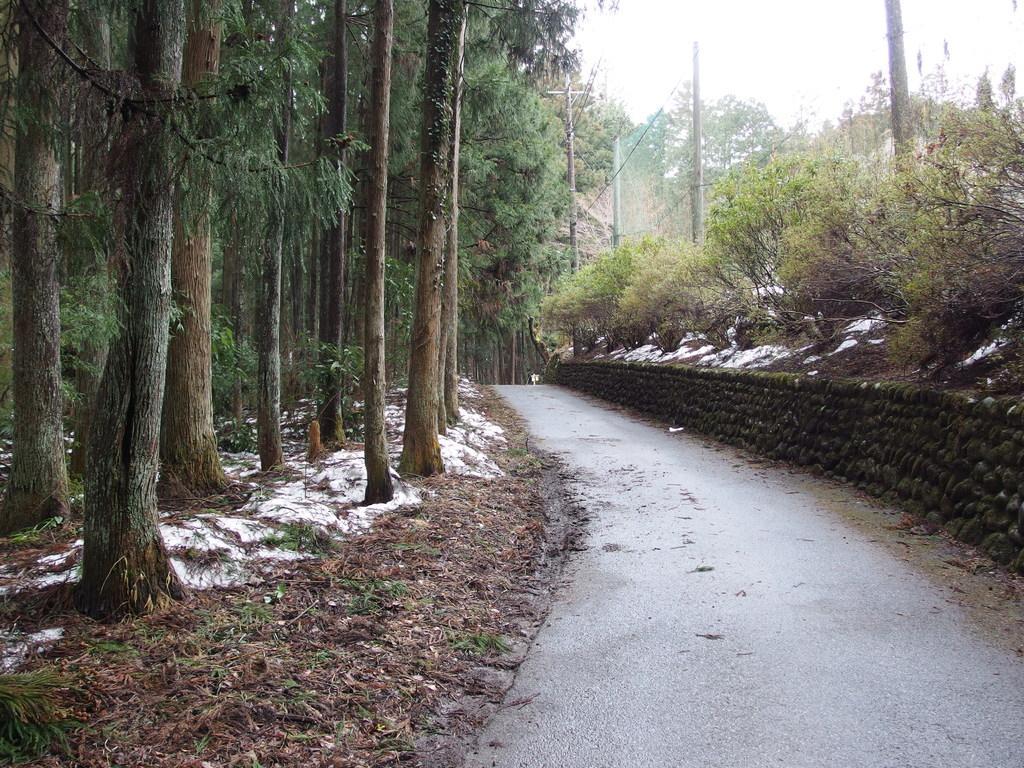Describe this image in one or two sentences. In this image we can see trees, electric poles, electric cables, snow and shredded leaves on the ground, road and sky. 